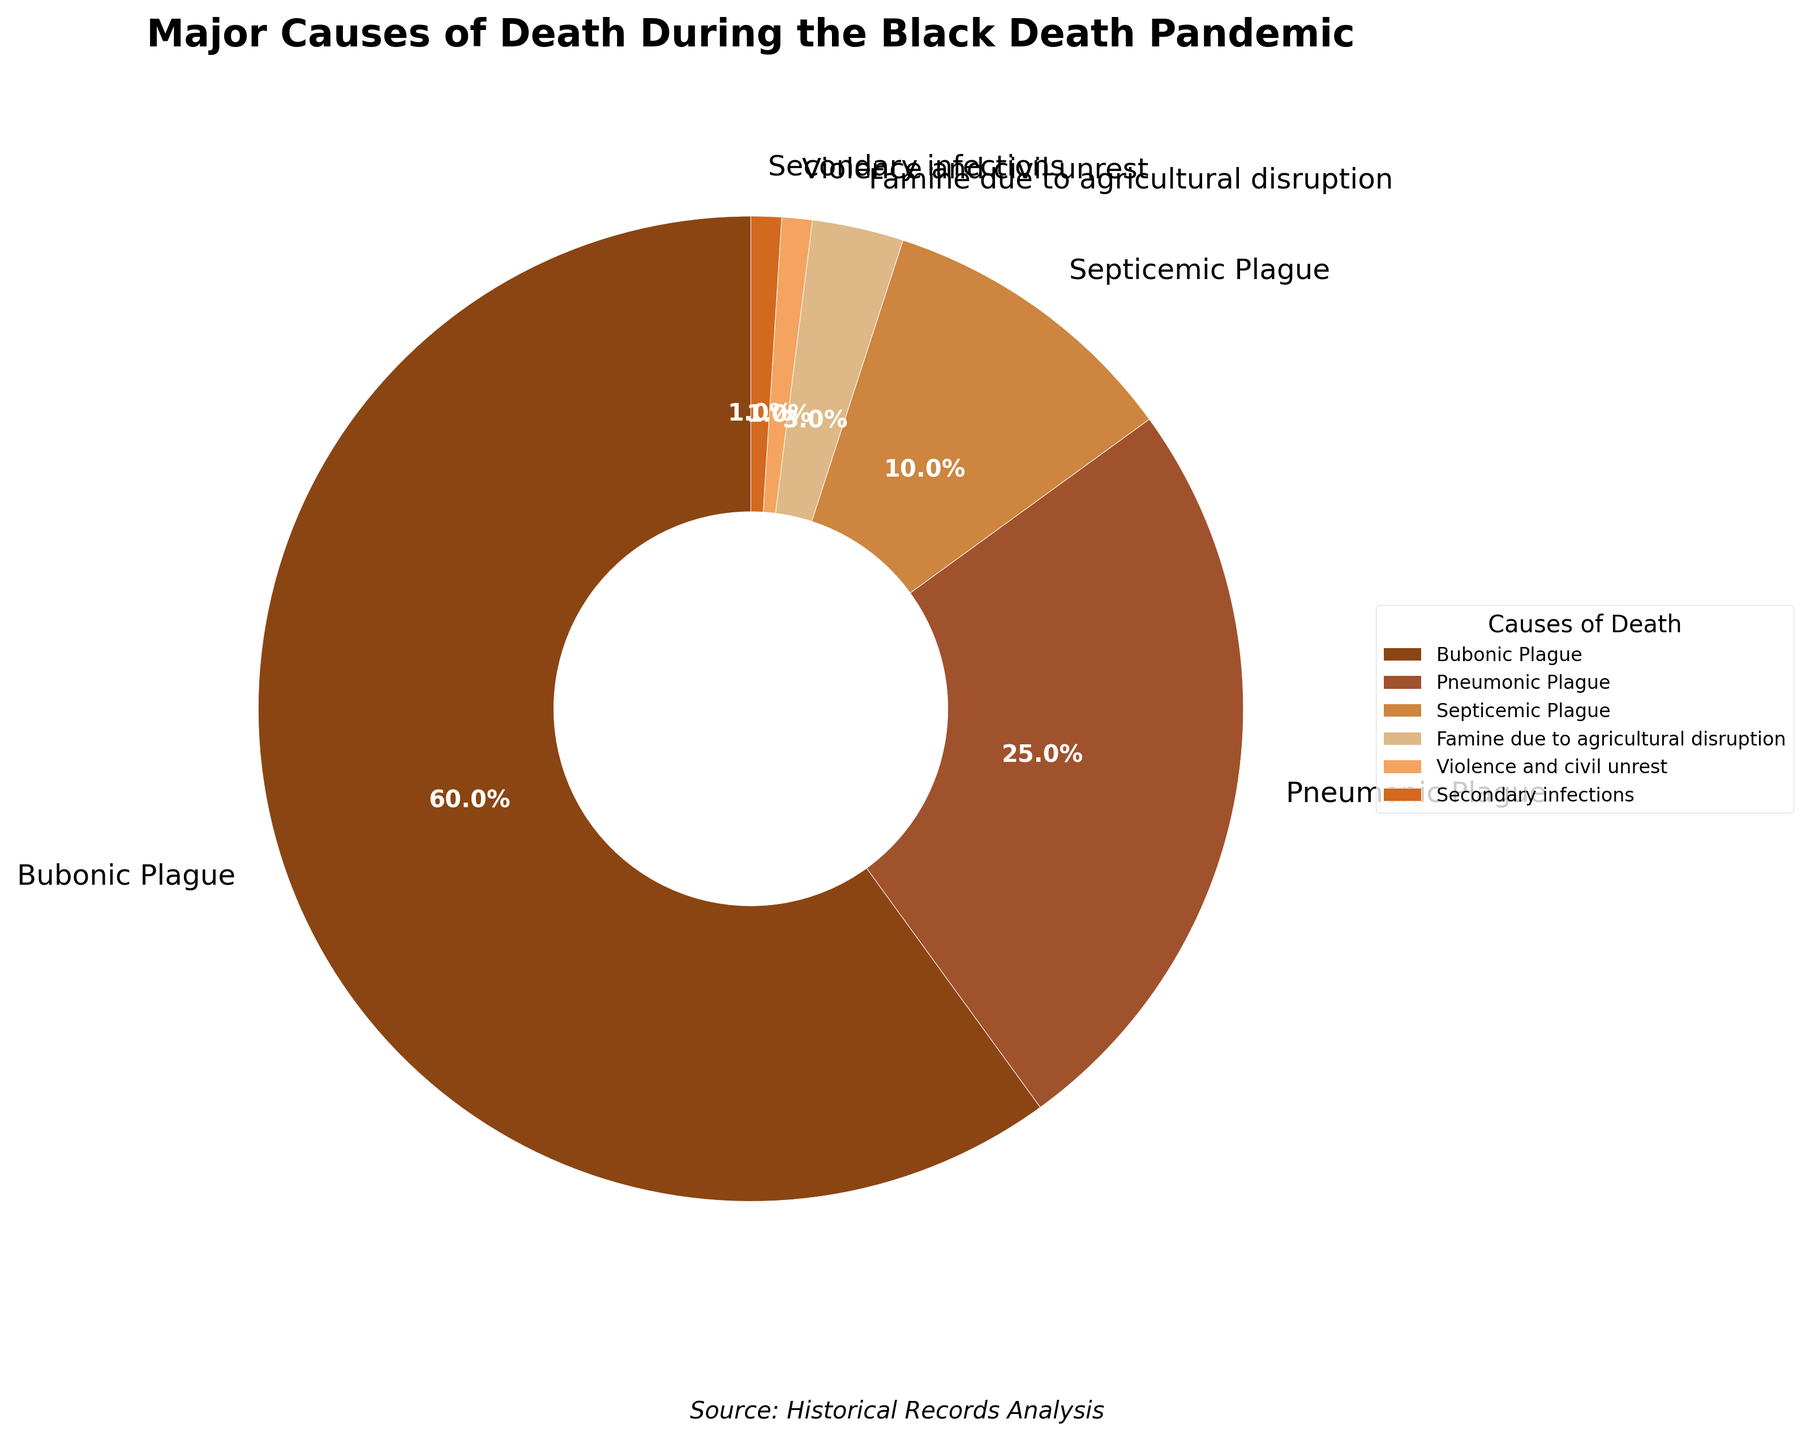What percentage of deaths were caused by diseases related to the plague? Add the percentages for all plague-related causes: Bubonic Plague (60%) + Pneumonic Plague (25%) + Septicemic Plague (10%).
Answer: 95% Which cause of death has the smallest percentage? Look at the pie chart and find the segment with the smallest value. Violence and civil unrest, and Secondary infections both have 1%.
Answer: Violence and civil unrest, Secondary infections How much larger is the percentage of deaths due to Bubonic Plague compared to Septicemic Plague? Subtract the percentage of Septicemic Plague (10%) from Bubonic Plague (60%).
Answer: 50% What are the top three causes of death during the Black Death pandemic in descending order? Identify the three largest segments in the pie chart: Bubonic Plague (60%), Pneumonic Plague (25%), and Septicemic Plague (10%).
Answer: Bubonic Plague, Pneumonic Plague, Septicemic Plague What is the combined percentage of deaths due to non-disease causes? Add the percentages for Famine due to agricultural disruption (3%) + Violence and civil unrest (1%) + Secondary infections (1%).
Answer: 5% Which segment represents the second smallest cause of death? Identify the second smallest segment which is Famine due to agricultural disruption (3%).
Answer: Famine due to agricultural disruption By how much does the percentage of deaths due to Pneumonic Plague exceed the combined percentage of deaths due to Famine and Violence? The percentage for Pneumonic Plague is 25%. Add the percentages of deaths due to Famine (3%) and Violence (1%) to get 4%. Subtract 4% from 25%.
Answer: 21% What three colors represent the segments for Bubonic Plague, Pneumonic Plague, and Septicemic Plague? Identify the colors associated with these segments from the pie chart: Bubonic Plague (dark brown), Pneumonic Plague (brown), Septicemic Plague (tan).
Answer: Dark brown, brown, tan What is the difference in percentage between deaths caused by Bubonic Plague and Famine due to agricultural disruption? Subtract the percentage for Famine due to agricultural disruption (3%) from Bubonic Plague (60%).
Answer: 57% What is the least common cause of death among those shown? Look at the pie chart and find the segment with the smallest value. Violence and civil unrest, and Secondary infections both have 1%.
Answer: Violence and civil unrest, Secondary infections 